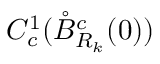<formula> <loc_0><loc_0><loc_500><loc_500>C _ { c } ^ { 1 } ( \mathring { B } _ { R _ { k } } ^ { c } ( 0 ) )</formula> 